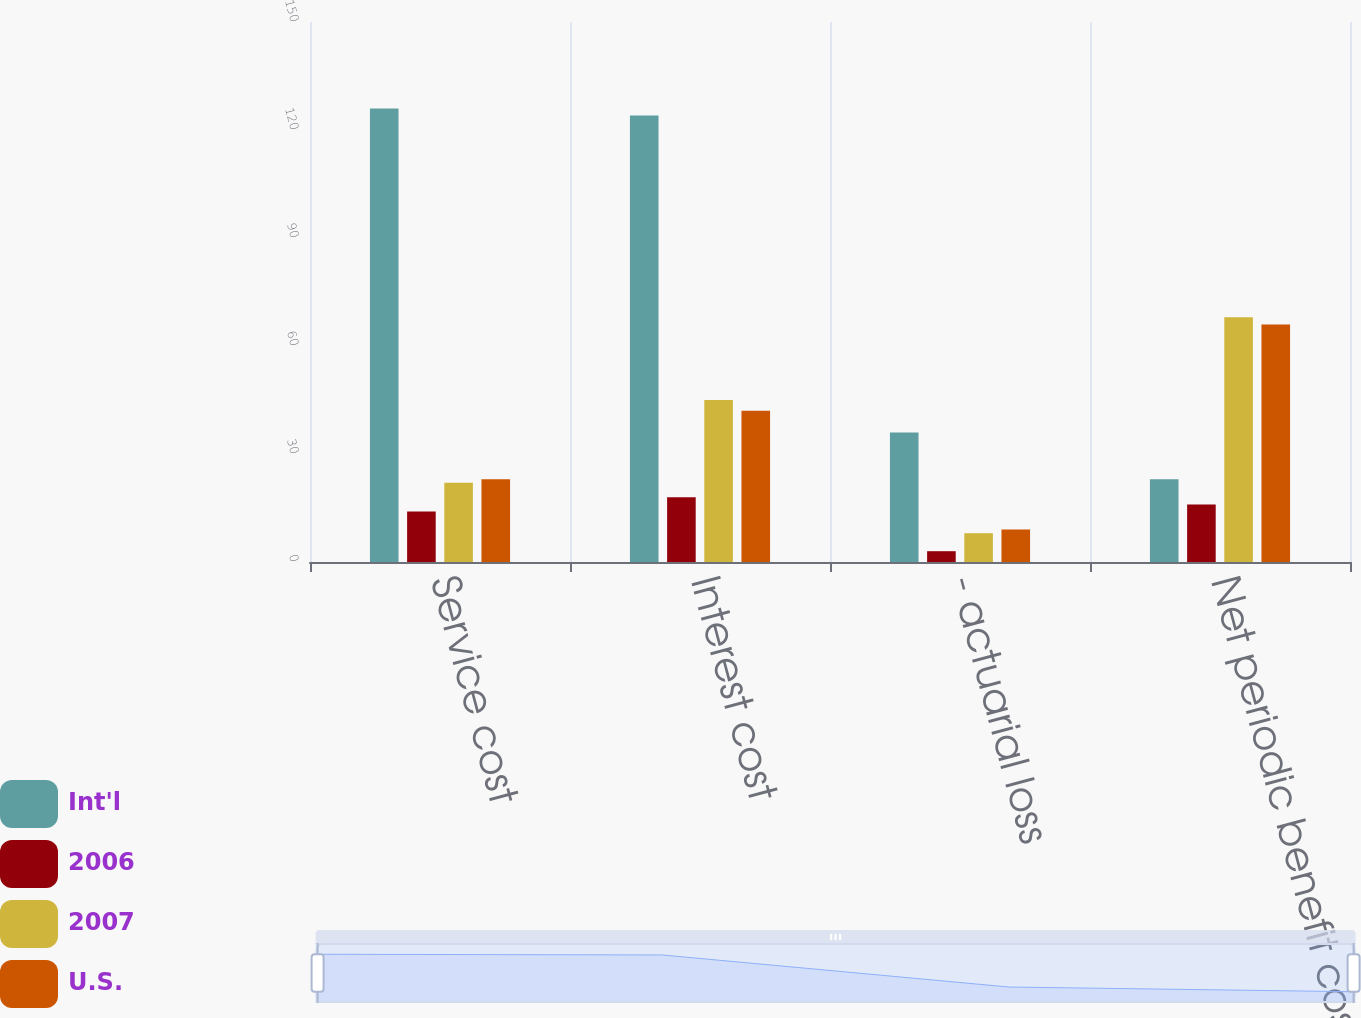Convert chart to OTSL. <chart><loc_0><loc_0><loc_500><loc_500><stacked_bar_chart><ecel><fcel>Service cost<fcel>Interest cost<fcel>- actuarial loss<fcel>Net periodic benefit cost<nl><fcel>Int'l<fcel>126<fcel>124<fcel>36<fcel>23<nl><fcel>2006<fcel>14<fcel>18<fcel>3<fcel>16<nl><fcel>2007<fcel>22<fcel>45<fcel>8<fcel>68<nl><fcel>U.S.<fcel>23<fcel>42<fcel>9<fcel>66<nl></chart> 